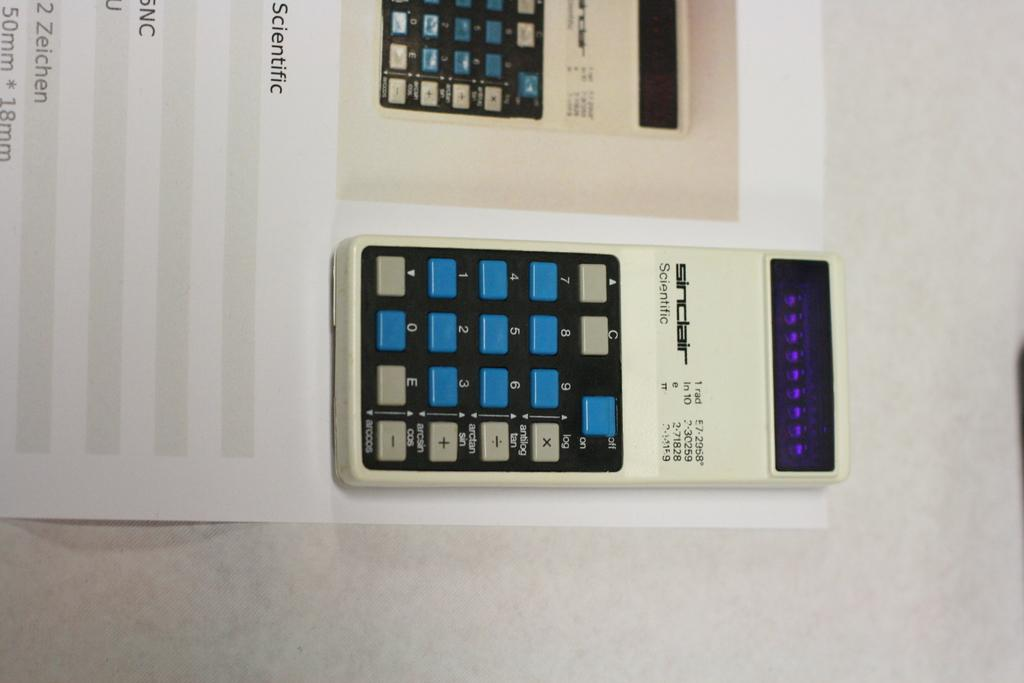<image>
Summarize the visual content of the image. A scientific calculator is made by the Sinclair company. 